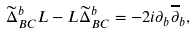Convert formula to latex. <formula><loc_0><loc_0><loc_500><loc_500>\widetilde { \Delta } _ { B C } ^ { b } L - L \widetilde { \Delta } _ { B C } ^ { b } = - 2 i \partial _ { b } \overline { \partial } _ { b } ,</formula> 